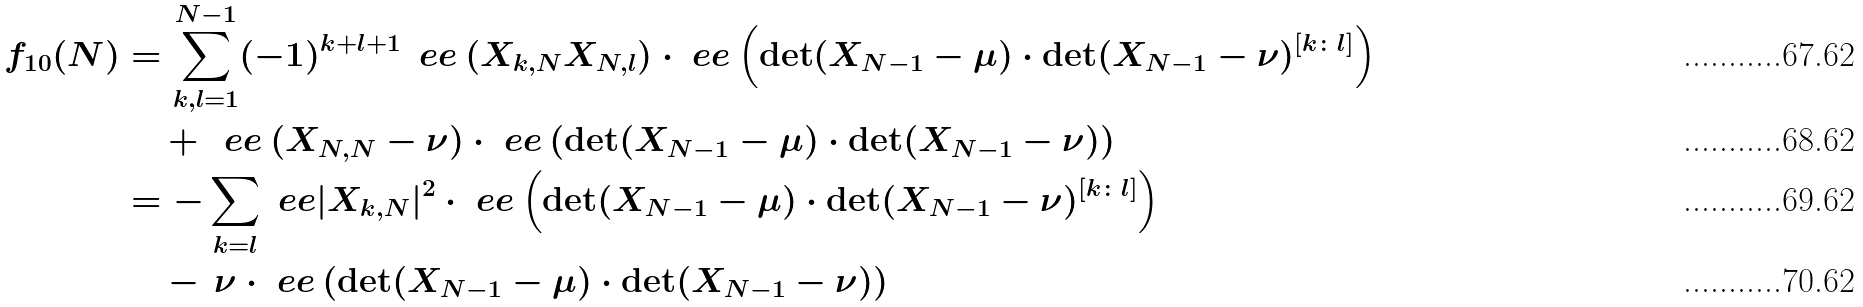Convert formula to latex. <formula><loc_0><loc_0><loc_500><loc_500>f _ { 1 0 } ( N ) & = \sum _ { k , l = 1 } ^ { N - 1 } ( - 1 ) ^ { k + l + 1 } \, \ e e \left ( X _ { k , N } X _ { N , l } \right ) \cdot \ e e \left ( \det ( X _ { N - 1 } - \mu ) \cdot \det ( X _ { N - 1 } - \nu ) ^ { [ k \colon l ] } \right ) \\ & \quad \, + \, \ e e \left ( X _ { N , N } - \nu \right ) \cdot \ e e \left ( \det ( X _ { N - 1 } - \mu ) \cdot \det ( X _ { N - 1 } - \nu ) \right ) \\ & = - \sum _ { k = l } \ e e | X _ { k , N } | ^ { 2 } \cdot \ e e \left ( \det ( X _ { N - 1 } - \mu ) \cdot \det ( X _ { N - 1 } - \nu ) ^ { [ k \colon l ] } \right ) \\ & \quad \, - \, \nu \cdot \ e e \left ( \det ( X _ { N - 1 } - \mu ) \cdot \det ( X _ { N - 1 } - \nu ) \right )</formula> 